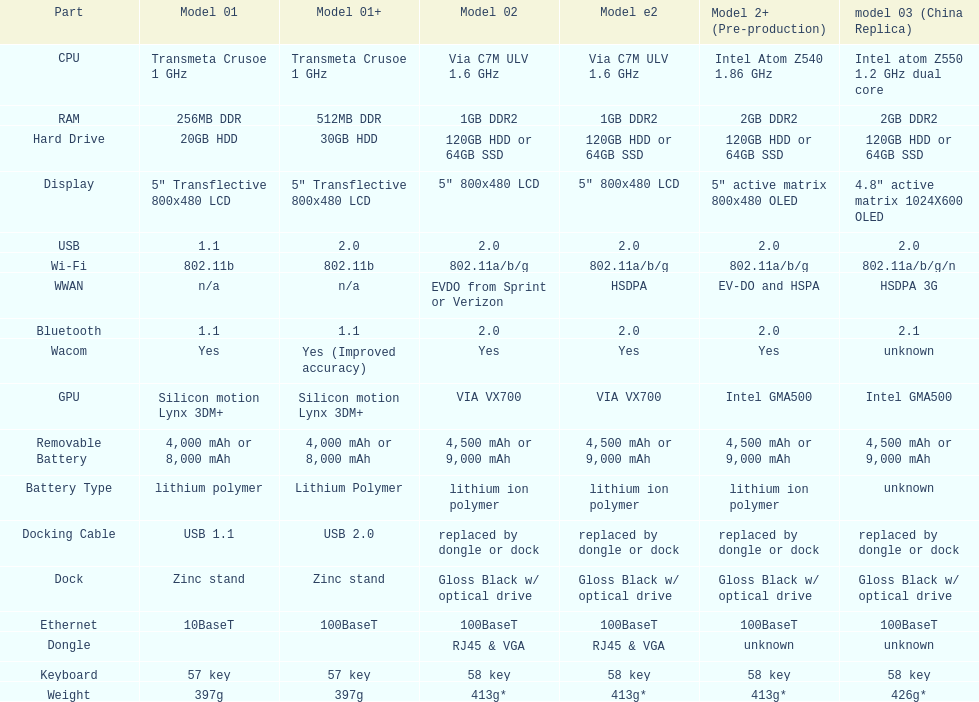How many models use a usb docking cable? 2. 